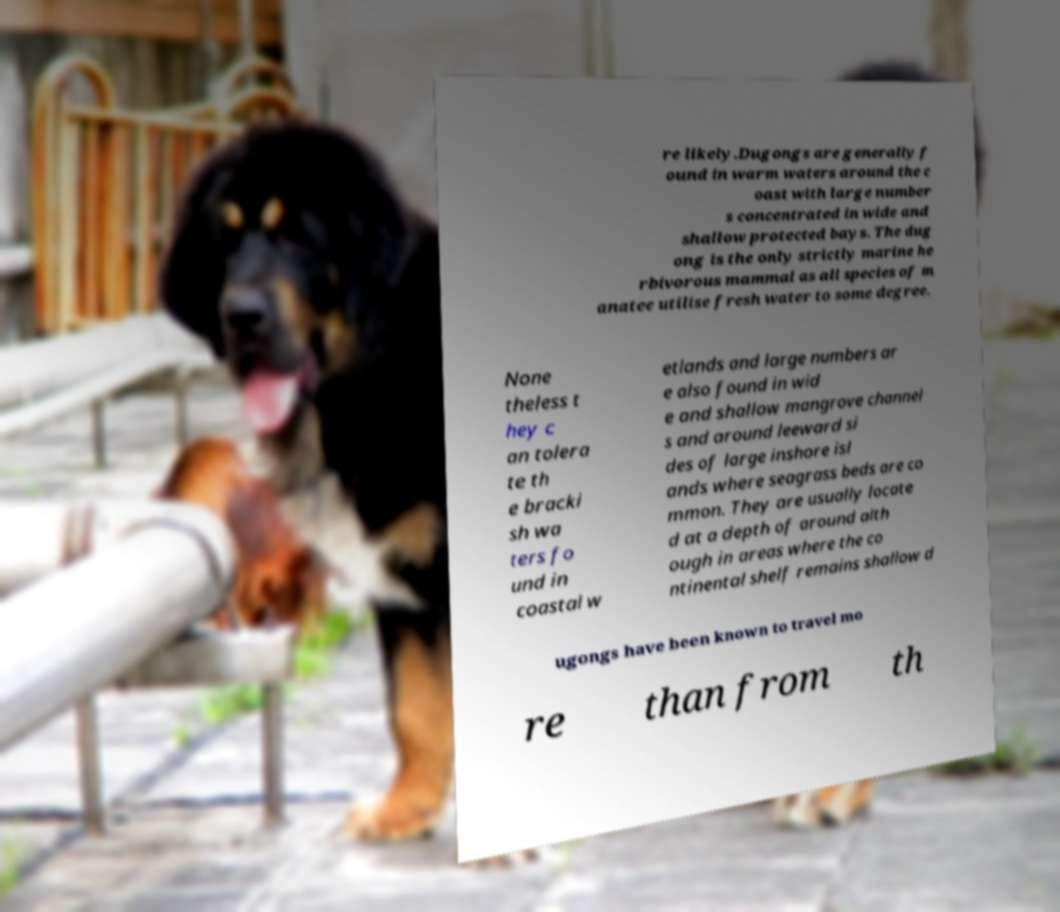Please read and relay the text visible in this image. What does it say? re likely.Dugongs are generally f ound in warm waters around the c oast with large number s concentrated in wide and shallow protected bays. The dug ong is the only strictly marine he rbivorous mammal as all species of m anatee utilise fresh water to some degree. None theless t hey c an tolera te th e bracki sh wa ters fo und in coastal w etlands and large numbers ar e also found in wid e and shallow mangrove channel s and around leeward si des of large inshore isl ands where seagrass beds are co mmon. They are usually locate d at a depth of around alth ough in areas where the co ntinental shelf remains shallow d ugongs have been known to travel mo re than from th 